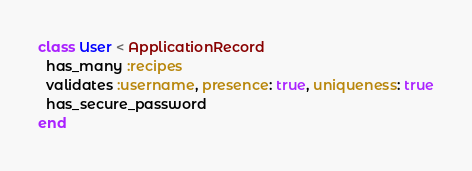<code> <loc_0><loc_0><loc_500><loc_500><_Ruby_>class User < ApplicationRecord
  has_many :recipes
  validates :username, presence: true, uniqueness: true
  has_secure_password
end
</code> 